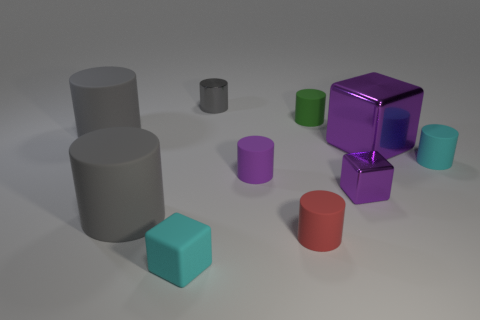What could be the purpose of this image? This image might be used for a variety of purposes such as a 3D modeling and rendering exercise, a demonstration of shape and shadow in a graphic design context, or as visual aids in educational materials to teach geometric concepts. 